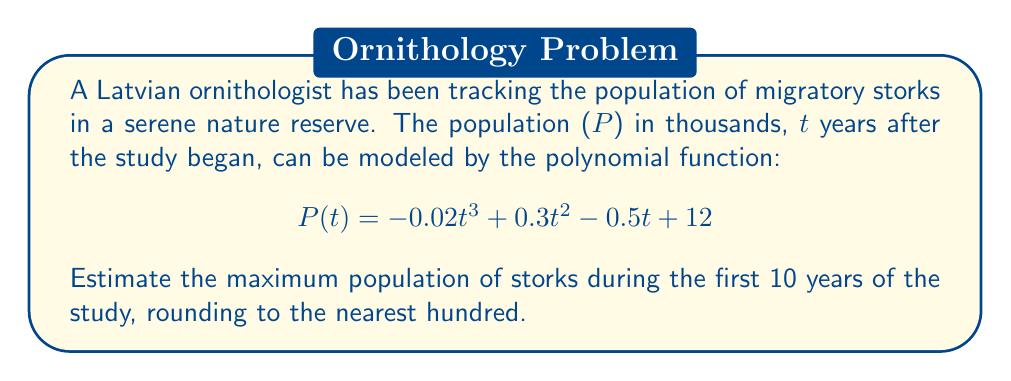Could you help me with this problem? To find the maximum population, we need to follow these steps:

1) First, we need to find the critical points of the function by taking the derivative and setting it equal to zero:

   $$P'(t) = -0.06t^2 + 0.6t - 0.5$$
   $$-0.06t^2 + 0.6t - 0.5 = 0$$

2) This is a quadratic equation. We can solve it using the quadratic formula:
   $$t = \frac{-b \pm \sqrt{b^2 - 4ac}}{2a}$$
   where $a = -0.06$, $b = 0.6$, and $c = -0.5$

3) Solving this:
   $$t = \frac{-0.6 \pm \sqrt{0.6^2 - 4(-0.06)(-0.5)}}{2(-0.06)}$$
   $$t = \frac{-0.6 \pm \sqrt{0.36 - 0.12}}{-0.12}$$
   $$t = \frac{-0.6 \pm \sqrt{0.24}}{-0.12} = \frac{-0.6 \pm 0.49}{-0.12}$$

4) This gives us two critical points:
   $$t_1 \approx 0.92 \text{ and } t_2 \approx 9.08$$

5) Since we're only interested in the first 10 years, both these points are relevant.

6) We need to evaluate $P(t)$ at $t = 0$, $t = 0.92$, $t = 9.08$, and $t = 10$ to find the maximum:

   $P(0) = 12$
   $P(0.92) \approx 12.21$
   $P(9.08) \approx 17.95$
   $P(10) \approx 17$

7) The maximum value occurs at $t \approx 9.08$ years, with $P(9.08) \approx 17.95$ thousand storks.

8) Rounding to the nearest hundred, we get 17,900 storks.
Answer: 17,900 storks 